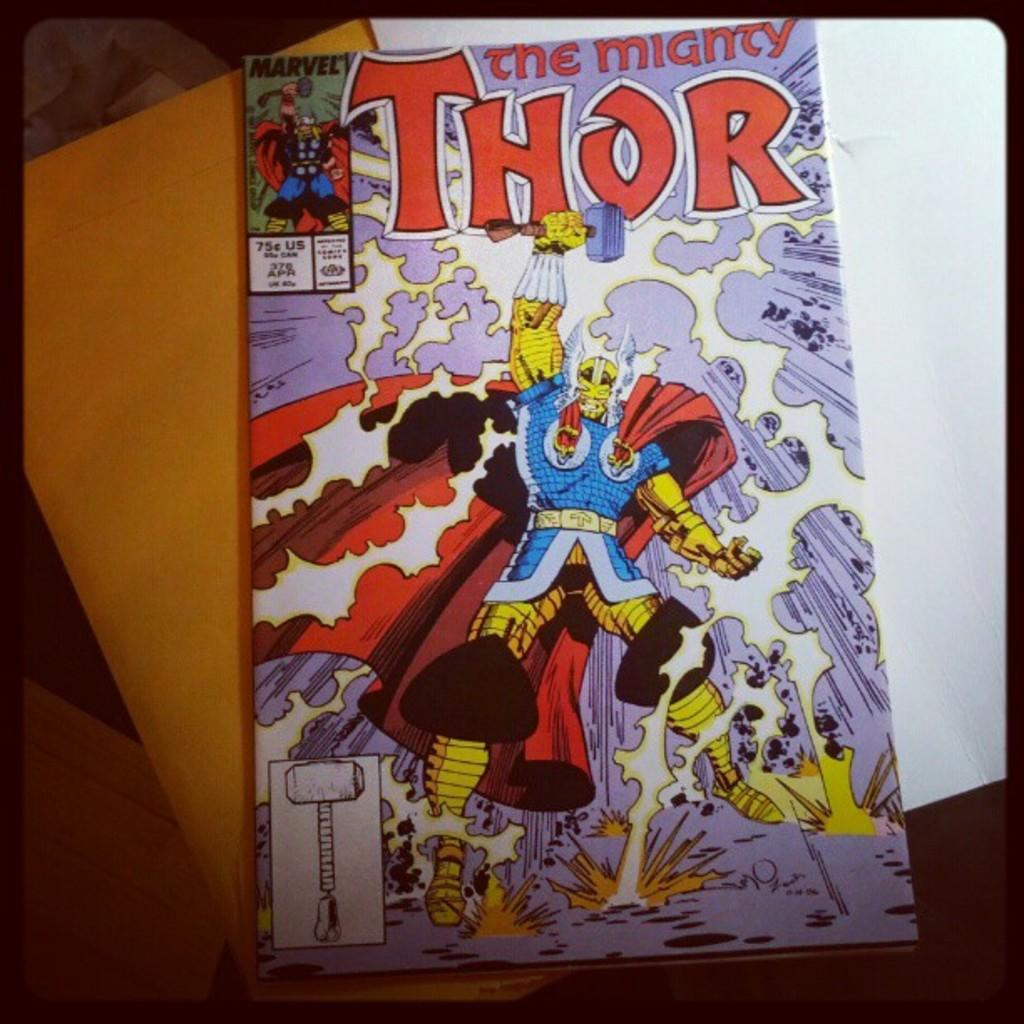<image>
Summarize the visual content of the image. A comic book for the Mighty Thor  priced at 75 cents. 